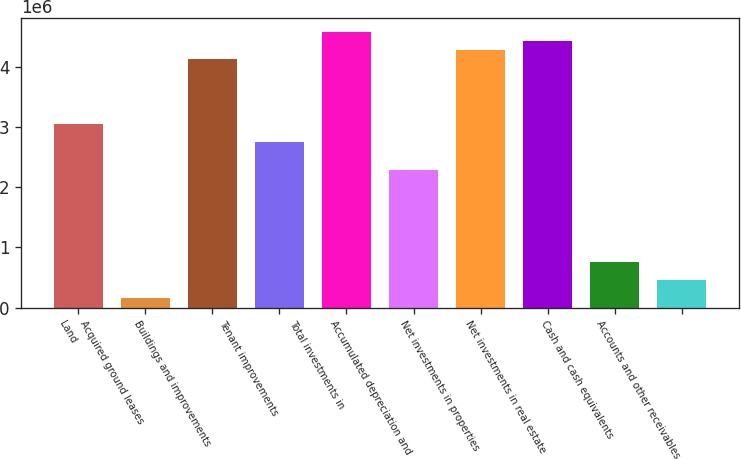Convert chart to OTSL. <chart><loc_0><loc_0><loc_500><loc_500><bar_chart><fcel>Land<fcel>Acquired ground leases<fcel>Buildings and improvements<fcel>Tenant improvements<fcel>Total investments in<fcel>Accumulated depreciation and<fcel>Net investments in properties<fcel>Net investments in real estate<fcel>Cash and cash equivalents<fcel>Accounts and other receivables<nl><fcel>3.05807e+06<fcel>153164<fcel>4.12829e+06<fcel>2.75229e+06<fcel>4.58696e+06<fcel>2.29362e+06<fcel>4.28118e+06<fcel>4.43407e+06<fcel>764722<fcel>458943<nl></chart> 